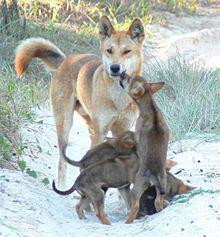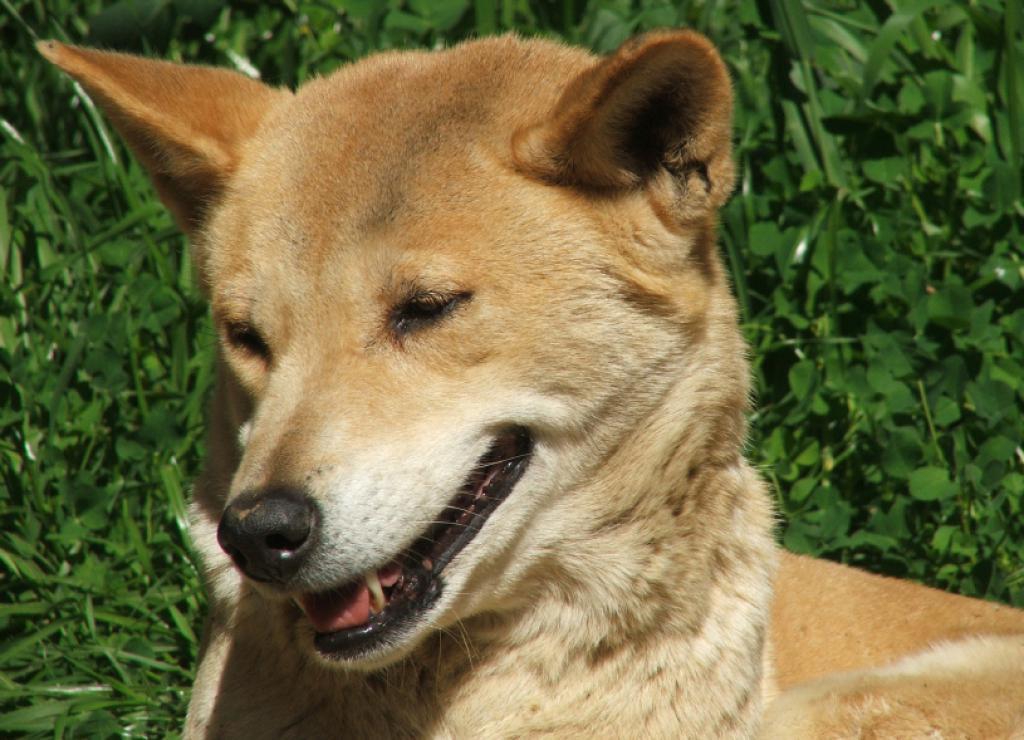The first image is the image on the left, the second image is the image on the right. Considering the images on both sides, is "At least one image features multiple dogs." valid? Answer yes or no. Yes. 